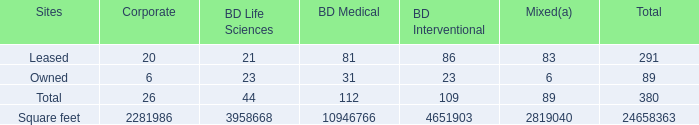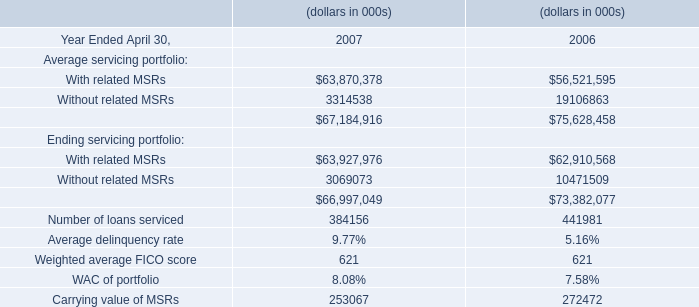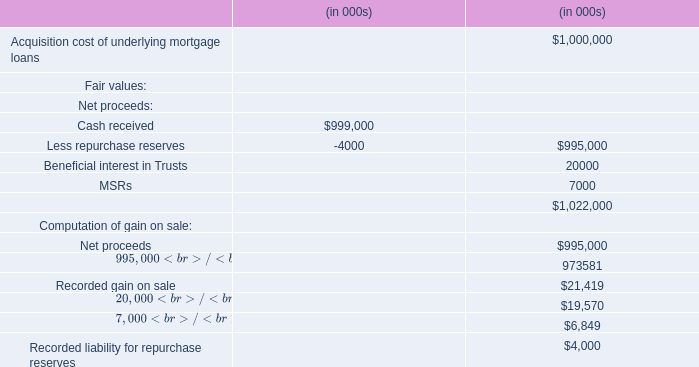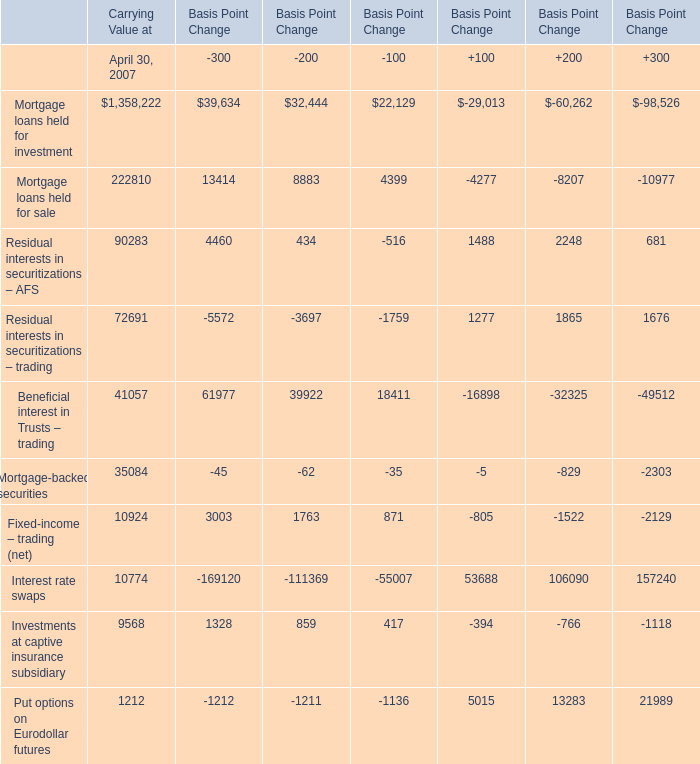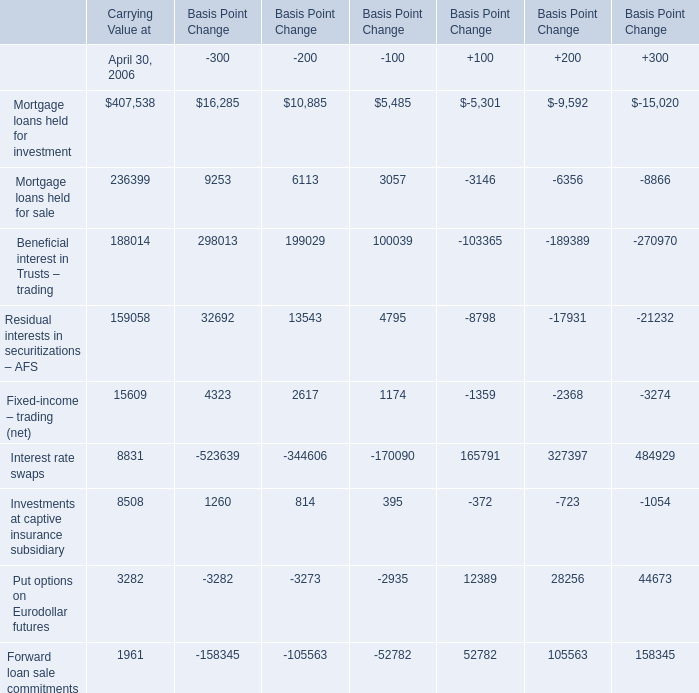What's the total amount of the Beneficial interest in Trusts – trading in the years where Mortgage loans held for investment of Carrying Value greater than 0? 
Computations: ((((((41057 + 61977) + 39922) + 18411) - 16898) - 32325) - 49512)
Answer: 62632.0. 